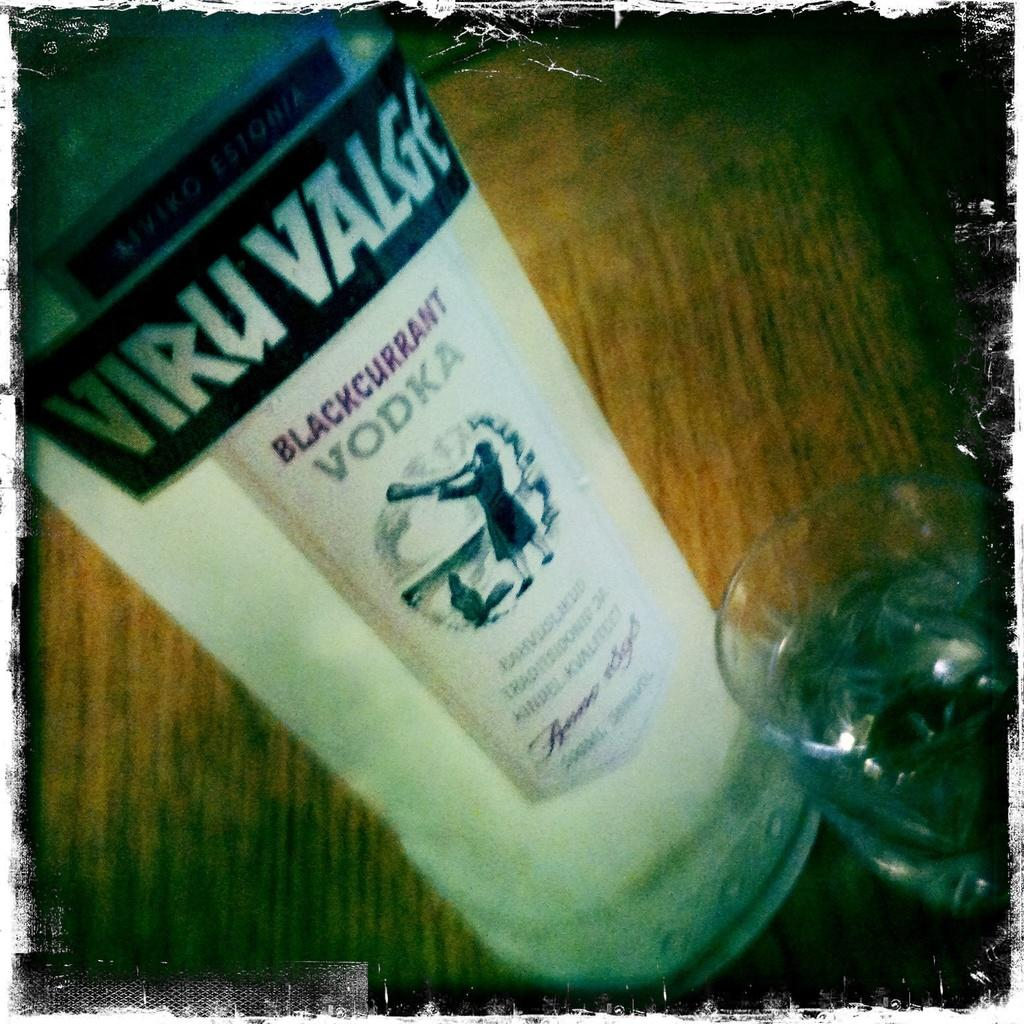<image>
Present a compact description of the photo's key features. A bottle of Blackcurrant Vodka  sits on a wooden table. 